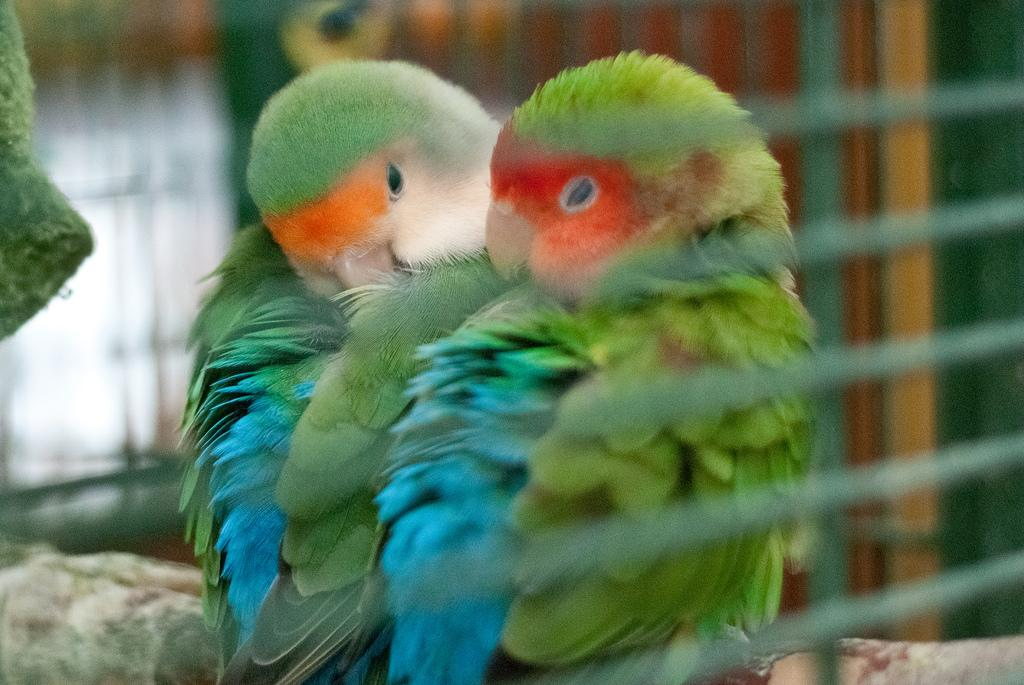How many birds are present in the image? There are two birds in the image. What colors can be seen on the birds? The birds have green, blue, and orange colors. Can you describe the background of the image? The background of the image is blurred. What type of plough is being used by the family in the image? There is no plough or family present in the image; it features two birds with green, blue, and orange colors against a blurred background. 